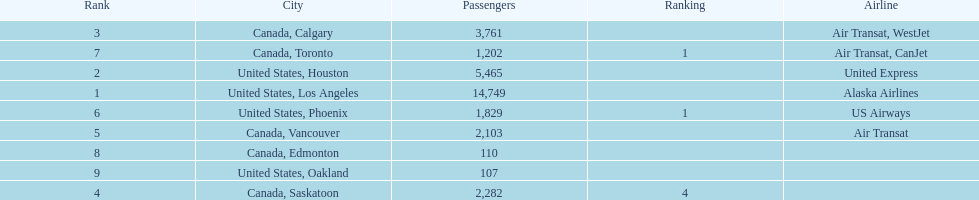The least number of passengers came from which city United States, Oakland. 